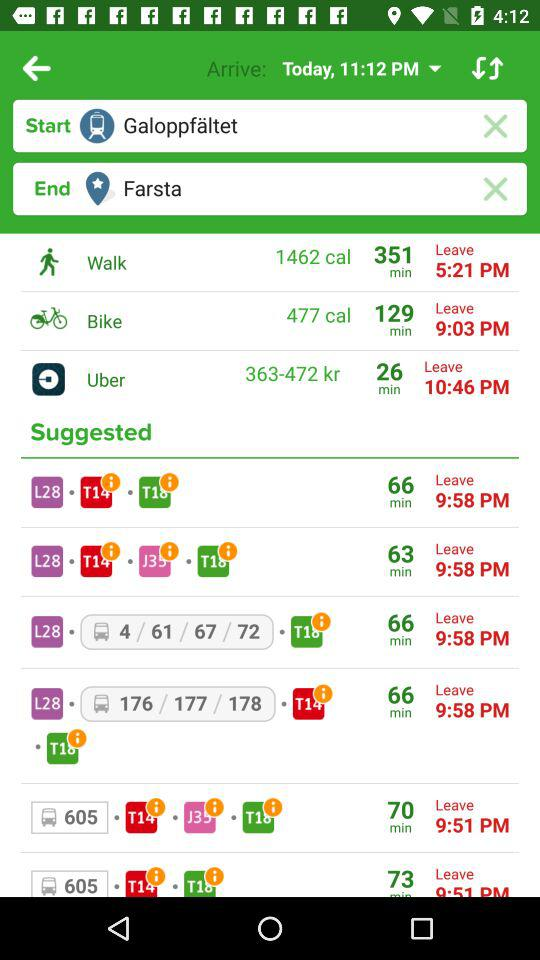What is the end location? The end location is Farsta. 